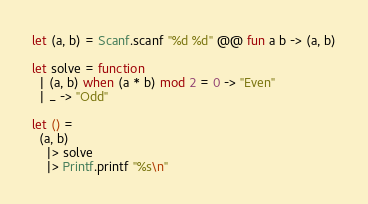<code> <loc_0><loc_0><loc_500><loc_500><_OCaml_>let (a, b) = Scanf.scanf "%d %d" @@ fun a b -> (a, b)

let solve = function
  | (a, b) when (a * b) mod 2 = 0 -> "Even"
  | _ -> "Odd"

let () =
  (a, b)
    |> solve
    |> Printf.printf "%s\n"</code> 